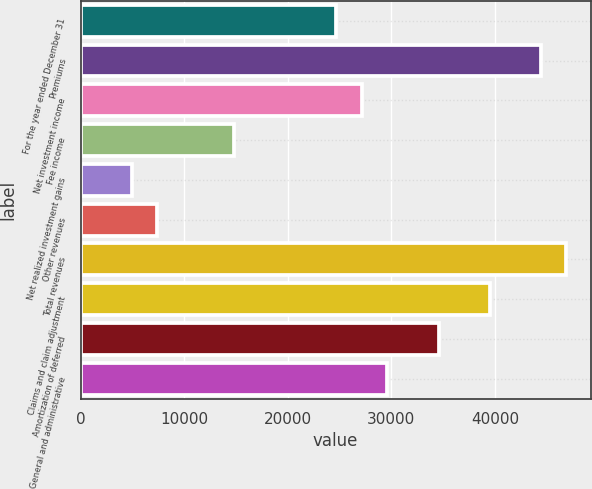<chart> <loc_0><loc_0><loc_500><loc_500><bar_chart><fcel>For the year ended December 31<fcel>Premiums<fcel>Net investment income<fcel>Fee income<fcel>Net realized investment gains<fcel>Other revenues<fcel>Total revenues<fcel>Claims and claim adjustment<fcel>Amortization of deferred<fcel>General and administrative<nl><fcel>24680<fcel>44419<fcel>27147.4<fcel>14810.5<fcel>4941.07<fcel>7408.44<fcel>46886.4<fcel>39484.2<fcel>34549.5<fcel>29614.8<nl></chart> 